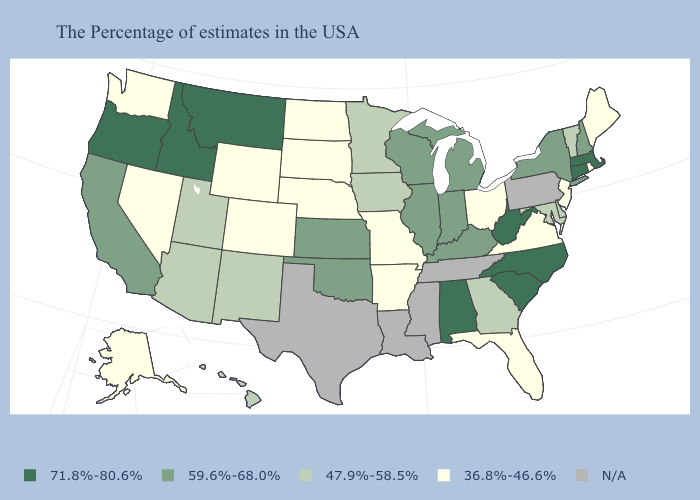Name the states that have a value in the range 36.8%-46.6%?
Short answer required. Maine, Rhode Island, New Jersey, Virginia, Ohio, Florida, Missouri, Arkansas, Nebraska, South Dakota, North Dakota, Wyoming, Colorado, Nevada, Washington, Alaska. Among the states that border Tennessee , does Georgia have the highest value?
Answer briefly. No. Which states have the highest value in the USA?
Quick response, please. Massachusetts, Connecticut, North Carolina, South Carolina, West Virginia, Alabama, Montana, Idaho, Oregon. Is the legend a continuous bar?
Answer briefly. No. Name the states that have a value in the range 36.8%-46.6%?
Write a very short answer. Maine, Rhode Island, New Jersey, Virginia, Ohio, Florida, Missouri, Arkansas, Nebraska, South Dakota, North Dakota, Wyoming, Colorado, Nevada, Washington, Alaska. Among the states that border Delaware , does New Jersey have the highest value?
Write a very short answer. No. What is the value of Montana?
Short answer required. 71.8%-80.6%. Name the states that have a value in the range 71.8%-80.6%?
Quick response, please. Massachusetts, Connecticut, North Carolina, South Carolina, West Virginia, Alabama, Montana, Idaho, Oregon. How many symbols are there in the legend?
Answer briefly. 5. What is the value of Oregon?
Answer briefly. 71.8%-80.6%. Name the states that have a value in the range 47.9%-58.5%?
Answer briefly. Vermont, Delaware, Maryland, Georgia, Minnesota, Iowa, New Mexico, Utah, Arizona, Hawaii. What is the highest value in the USA?
Keep it brief. 71.8%-80.6%. What is the value of Arizona?
Keep it brief. 47.9%-58.5%. 